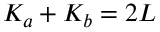<formula> <loc_0><loc_0><loc_500><loc_500>K _ { a } + K _ { b } = 2 L</formula> 